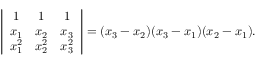Convert formula to latex. <formula><loc_0><loc_0><loc_500><loc_500>\left | { \begin{array} { c c c } { 1 } & { 1 } & { 1 } \\ { x _ { 1 } } & { x _ { 2 } } & { x _ { 3 } } \\ { x _ { 1 } ^ { 2 } } & { x _ { 2 } ^ { 2 } } & { x _ { 3 } ^ { 2 } } \end{array} } \right | = ( x _ { 3 } - x _ { 2 } ) ( x _ { 3 } - x _ { 1 } ) ( x _ { 2 } - x _ { 1 } ) .</formula> 